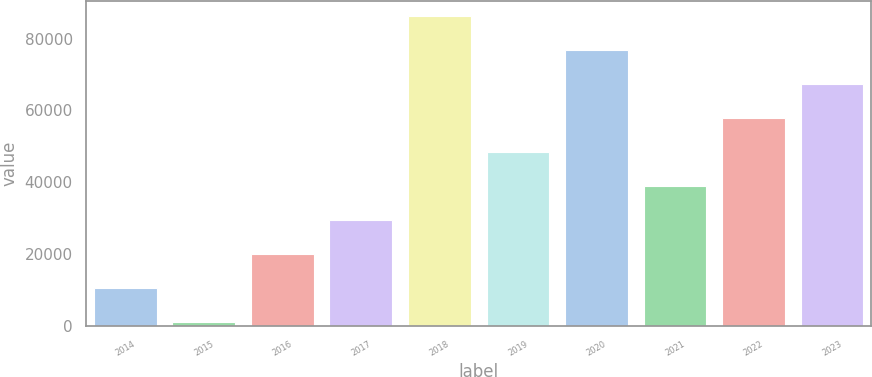Convert chart. <chart><loc_0><loc_0><loc_500><loc_500><bar_chart><fcel>2014<fcel>2015<fcel>2016<fcel>2017<fcel>2018<fcel>2019<fcel>2020<fcel>2021<fcel>2022<fcel>2023<nl><fcel>10649.7<fcel>1196<fcel>20103.4<fcel>29557.1<fcel>86279.3<fcel>48464.5<fcel>76825.6<fcel>39010.8<fcel>57918.2<fcel>67371.9<nl></chart> 